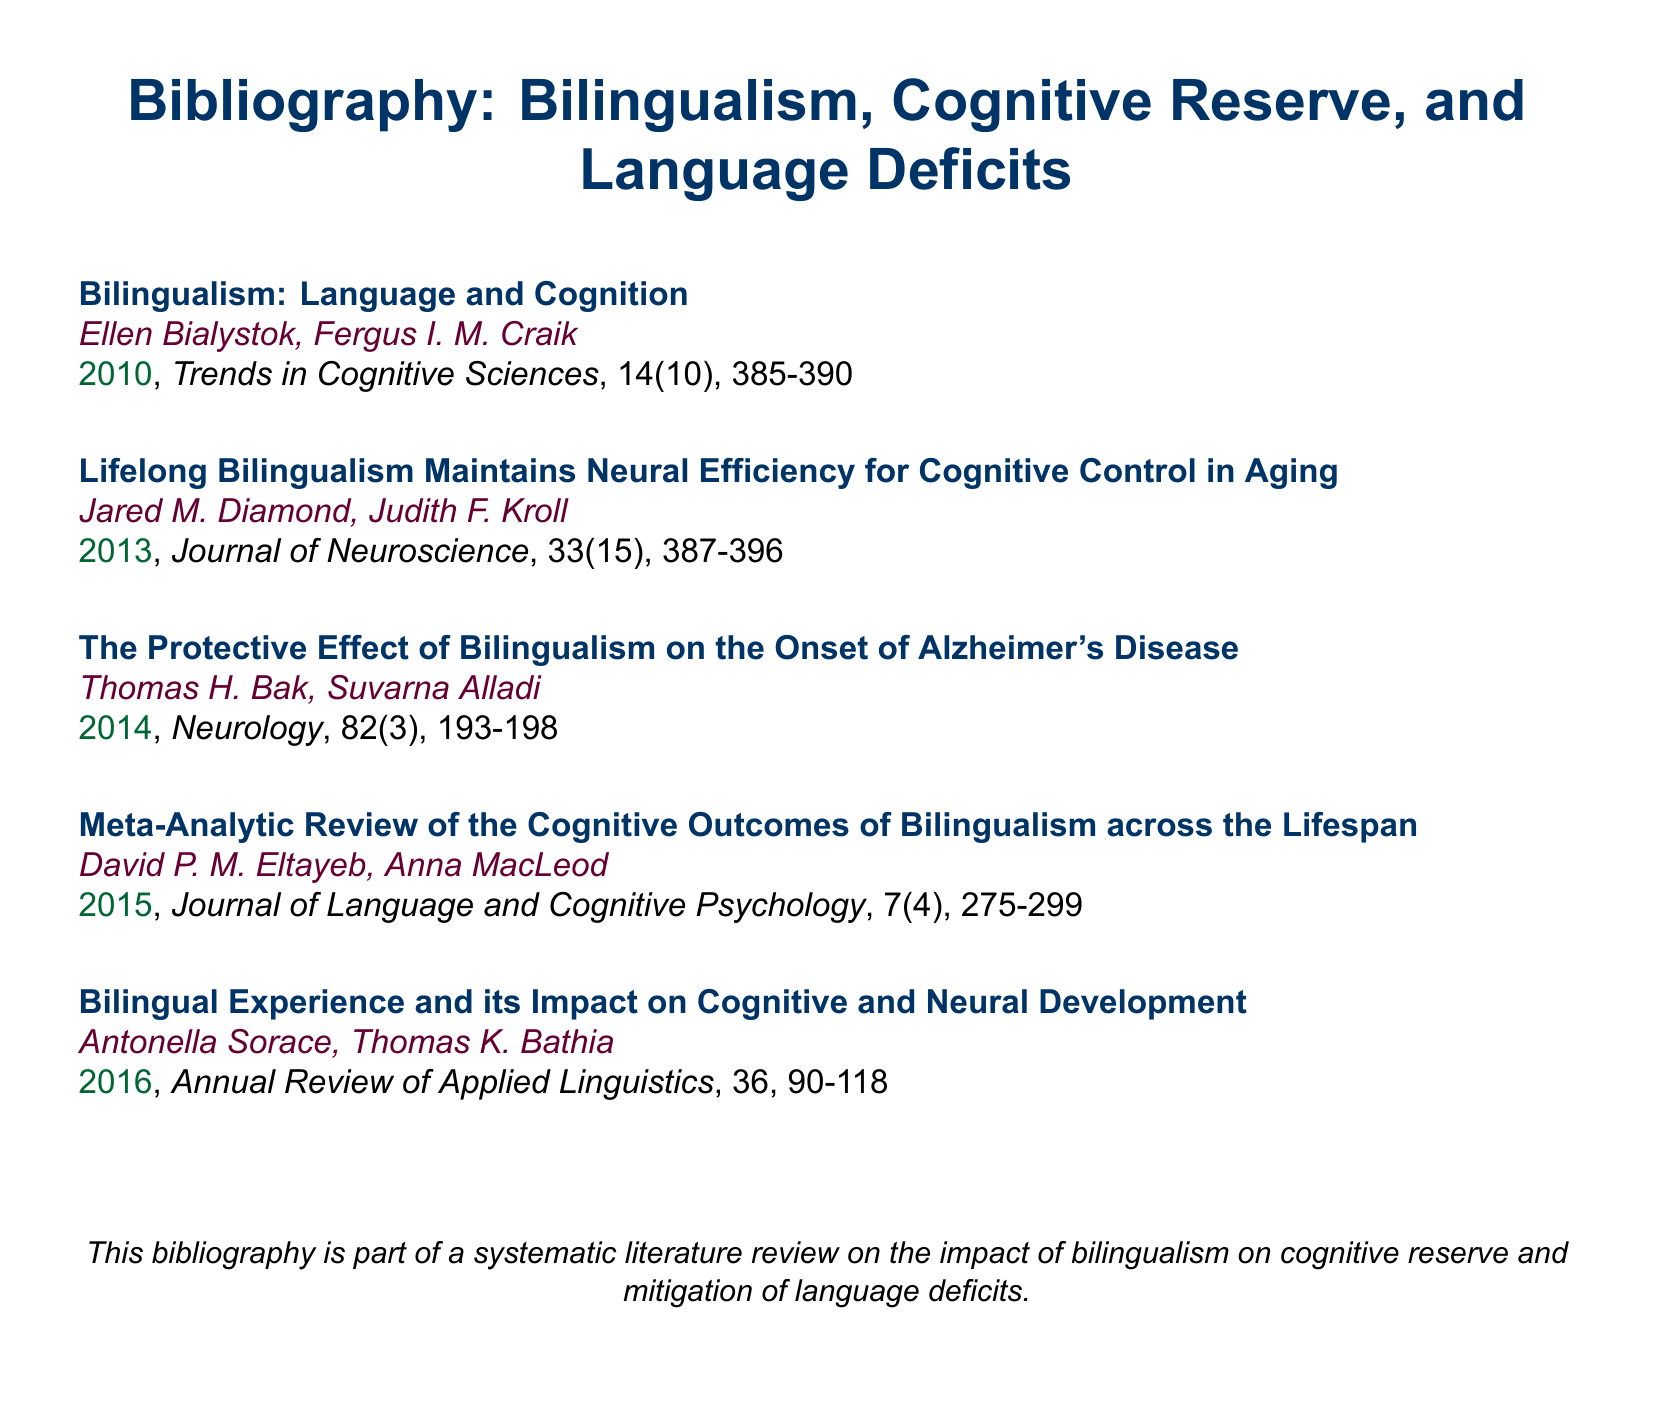what is the title of the document? The title is stated at the beginning of the document, highlighting the subject matter of the bibliography.
Answer: Bibliography: Bilingualism, Cognitive Reserve, and Language Deficits who are the authors of the first entry? The authors of the first entry are listed directly below the title of that entry in the document.
Answer: Ellen Bialystok, Fergus I. M. Craik what is the year of publication for the article on the protective effect of bilingualism? The year of publication is presented in the bibliographic format next to the title and author names.
Answer: 2014 which journal published the entry titled "Bilingual Experience and its Impact on Cognitive and Neural Development"? The journal name is typically included in the bibliographic entry format, indicating where the research was published.
Answer: Annual Review of Applied Linguistics which article discusses the meta-analytic review of cognitive outcomes of bilingualism? The title of the article can be located when reviewing the bibliography entries, along with author details and publication information.
Answer: Meta-Analytic Review of the Cognitive Outcomes of Bilingualism across the Lifespan what volume and issue number is associated with the article by Jared M. Diamond and Judith F. Kroll? The volume and issue number is traditionally included in the citation for clarity of reference.
Answer: 33(15) how many authors contributed to the entry on lifelong bilingualism? The number of authors is identified by counting the names listed in the corresponding bibliographic entry.
Answer: 2 what type of document is this? The type of document is indicated by the title and overall format, focusing on bibliographic references.
Answer: Bibliography 